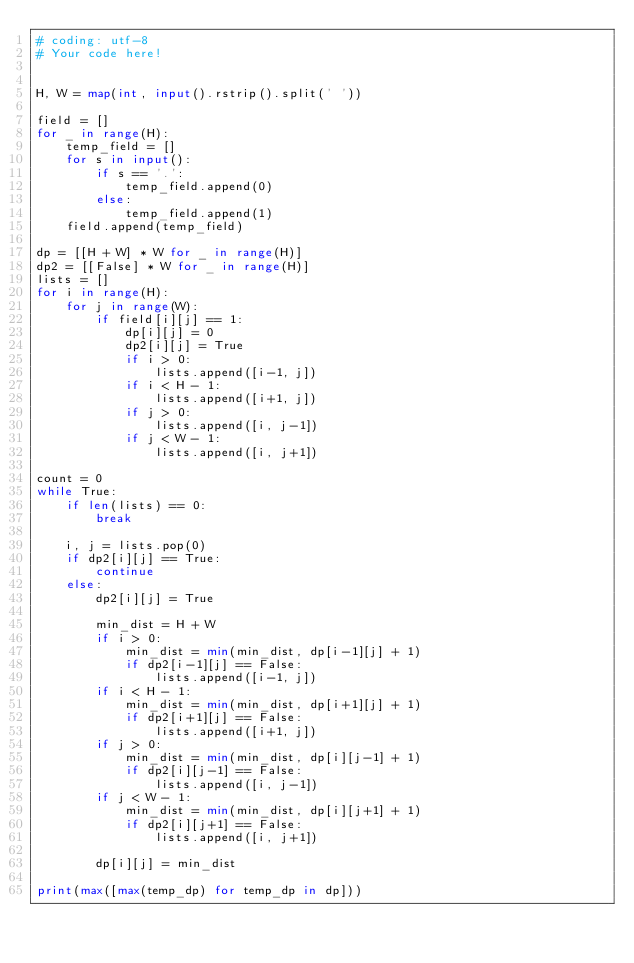<code> <loc_0><loc_0><loc_500><loc_500><_Python_># coding: utf-8
# Your code here!


H, W = map(int, input().rstrip().split(' '))

field = []
for _ in range(H):
    temp_field = []
    for s in input():
        if s == '.':
            temp_field.append(0)
        else:
            temp_field.append(1)
    field.append(temp_field)

dp = [[H + W] * W for _ in range(H)]
dp2 = [[False] * W for _ in range(H)]
lists = []
for i in range(H):
    for j in range(W):
        if field[i][j] == 1:
            dp[i][j] = 0
            dp2[i][j] = True
            if i > 0:
                lists.append([i-1, j])
            if i < H - 1:
                lists.append([i+1, j])
            if j > 0:
                lists.append([i, j-1])
            if j < W - 1:
                lists.append([i, j+1])
           
count = 0
while True:
    if len(lists) == 0:
        break
    
    i, j = lists.pop(0)
    if dp2[i][j] == True:
        continue
    else:
        dp2[i][j] = True
        
        min_dist = H + W
        if i > 0:
            min_dist = min(min_dist, dp[i-1][j] + 1)
            if dp2[i-1][j] == False:
                lists.append([i-1, j])
        if i < H - 1:
            min_dist = min(min_dist, dp[i+1][j] + 1)
            if dp2[i+1][j] == False:
                lists.append([i+1, j])
        if j > 0:
            min_dist = min(min_dist, dp[i][j-1] + 1)
            if dp2[i][j-1] == False:
                lists.append([i, j-1])
        if j < W - 1:
            min_dist = min(min_dist, dp[i][j+1] + 1)
            if dp2[i][j+1] == False:
                lists.append([i, j+1])
            
        dp[i][j] = min_dist
        
print(max([max(temp_dp) for temp_dp in dp]))</code> 